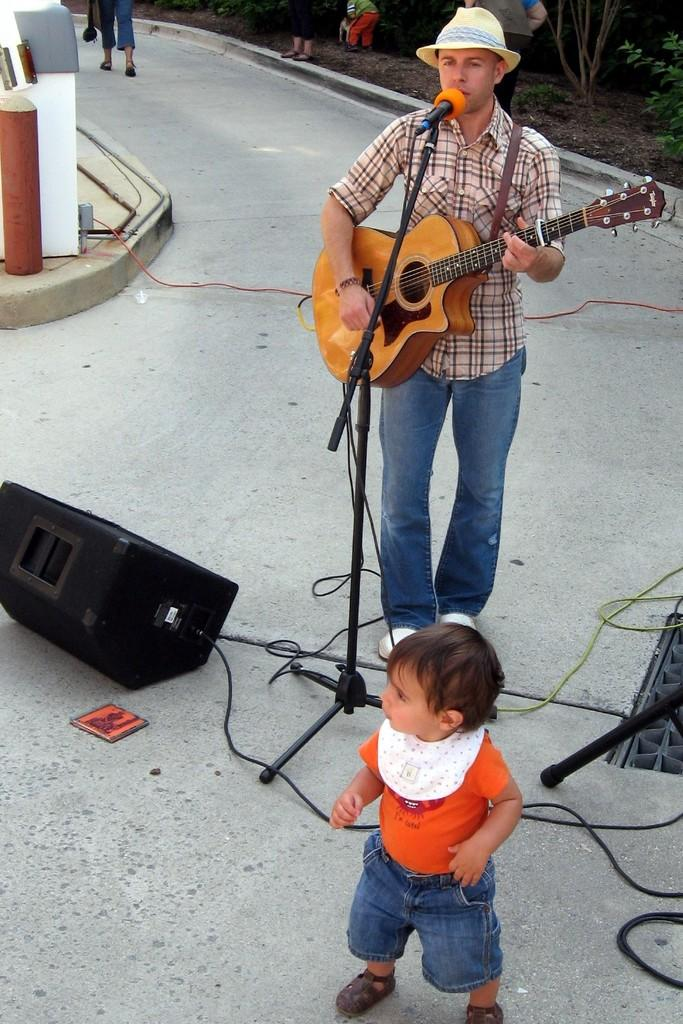What is the man in the image holding? The man is holding a guitar in the image. Who else is present in the image besides the man? There is a little kid in the image. What is the position of the kid in the image? The kid is standing on the ground in the image. What other object can be seen in the image? There is a speaker in the image. What color is the rose that the man is holding in the image? There is no rose present in the image; the man is holding a guitar. 